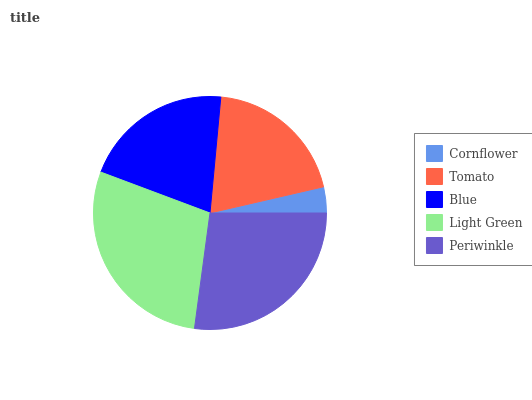Is Cornflower the minimum?
Answer yes or no. Yes. Is Light Green the maximum?
Answer yes or no. Yes. Is Tomato the minimum?
Answer yes or no. No. Is Tomato the maximum?
Answer yes or no. No. Is Tomato greater than Cornflower?
Answer yes or no. Yes. Is Cornflower less than Tomato?
Answer yes or no. Yes. Is Cornflower greater than Tomato?
Answer yes or no. No. Is Tomato less than Cornflower?
Answer yes or no. No. Is Blue the high median?
Answer yes or no. Yes. Is Blue the low median?
Answer yes or no. Yes. Is Periwinkle the high median?
Answer yes or no. No. Is Light Green the low median?
Answer yes or no. No. 